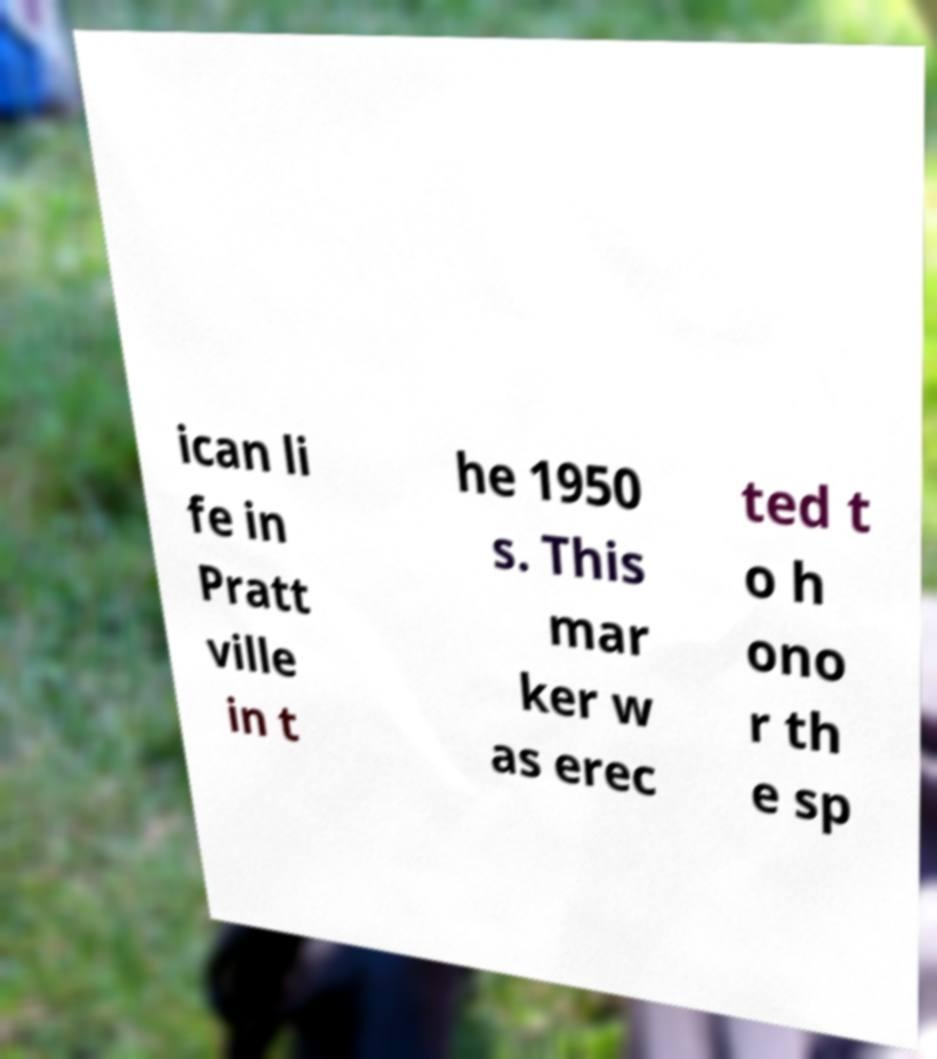Can you accurately transcribe the text from the provided image for me? ican li fe in Pratt ville in t he 1950 s. This mar ker w as erec ted t o h ono r th e sp 